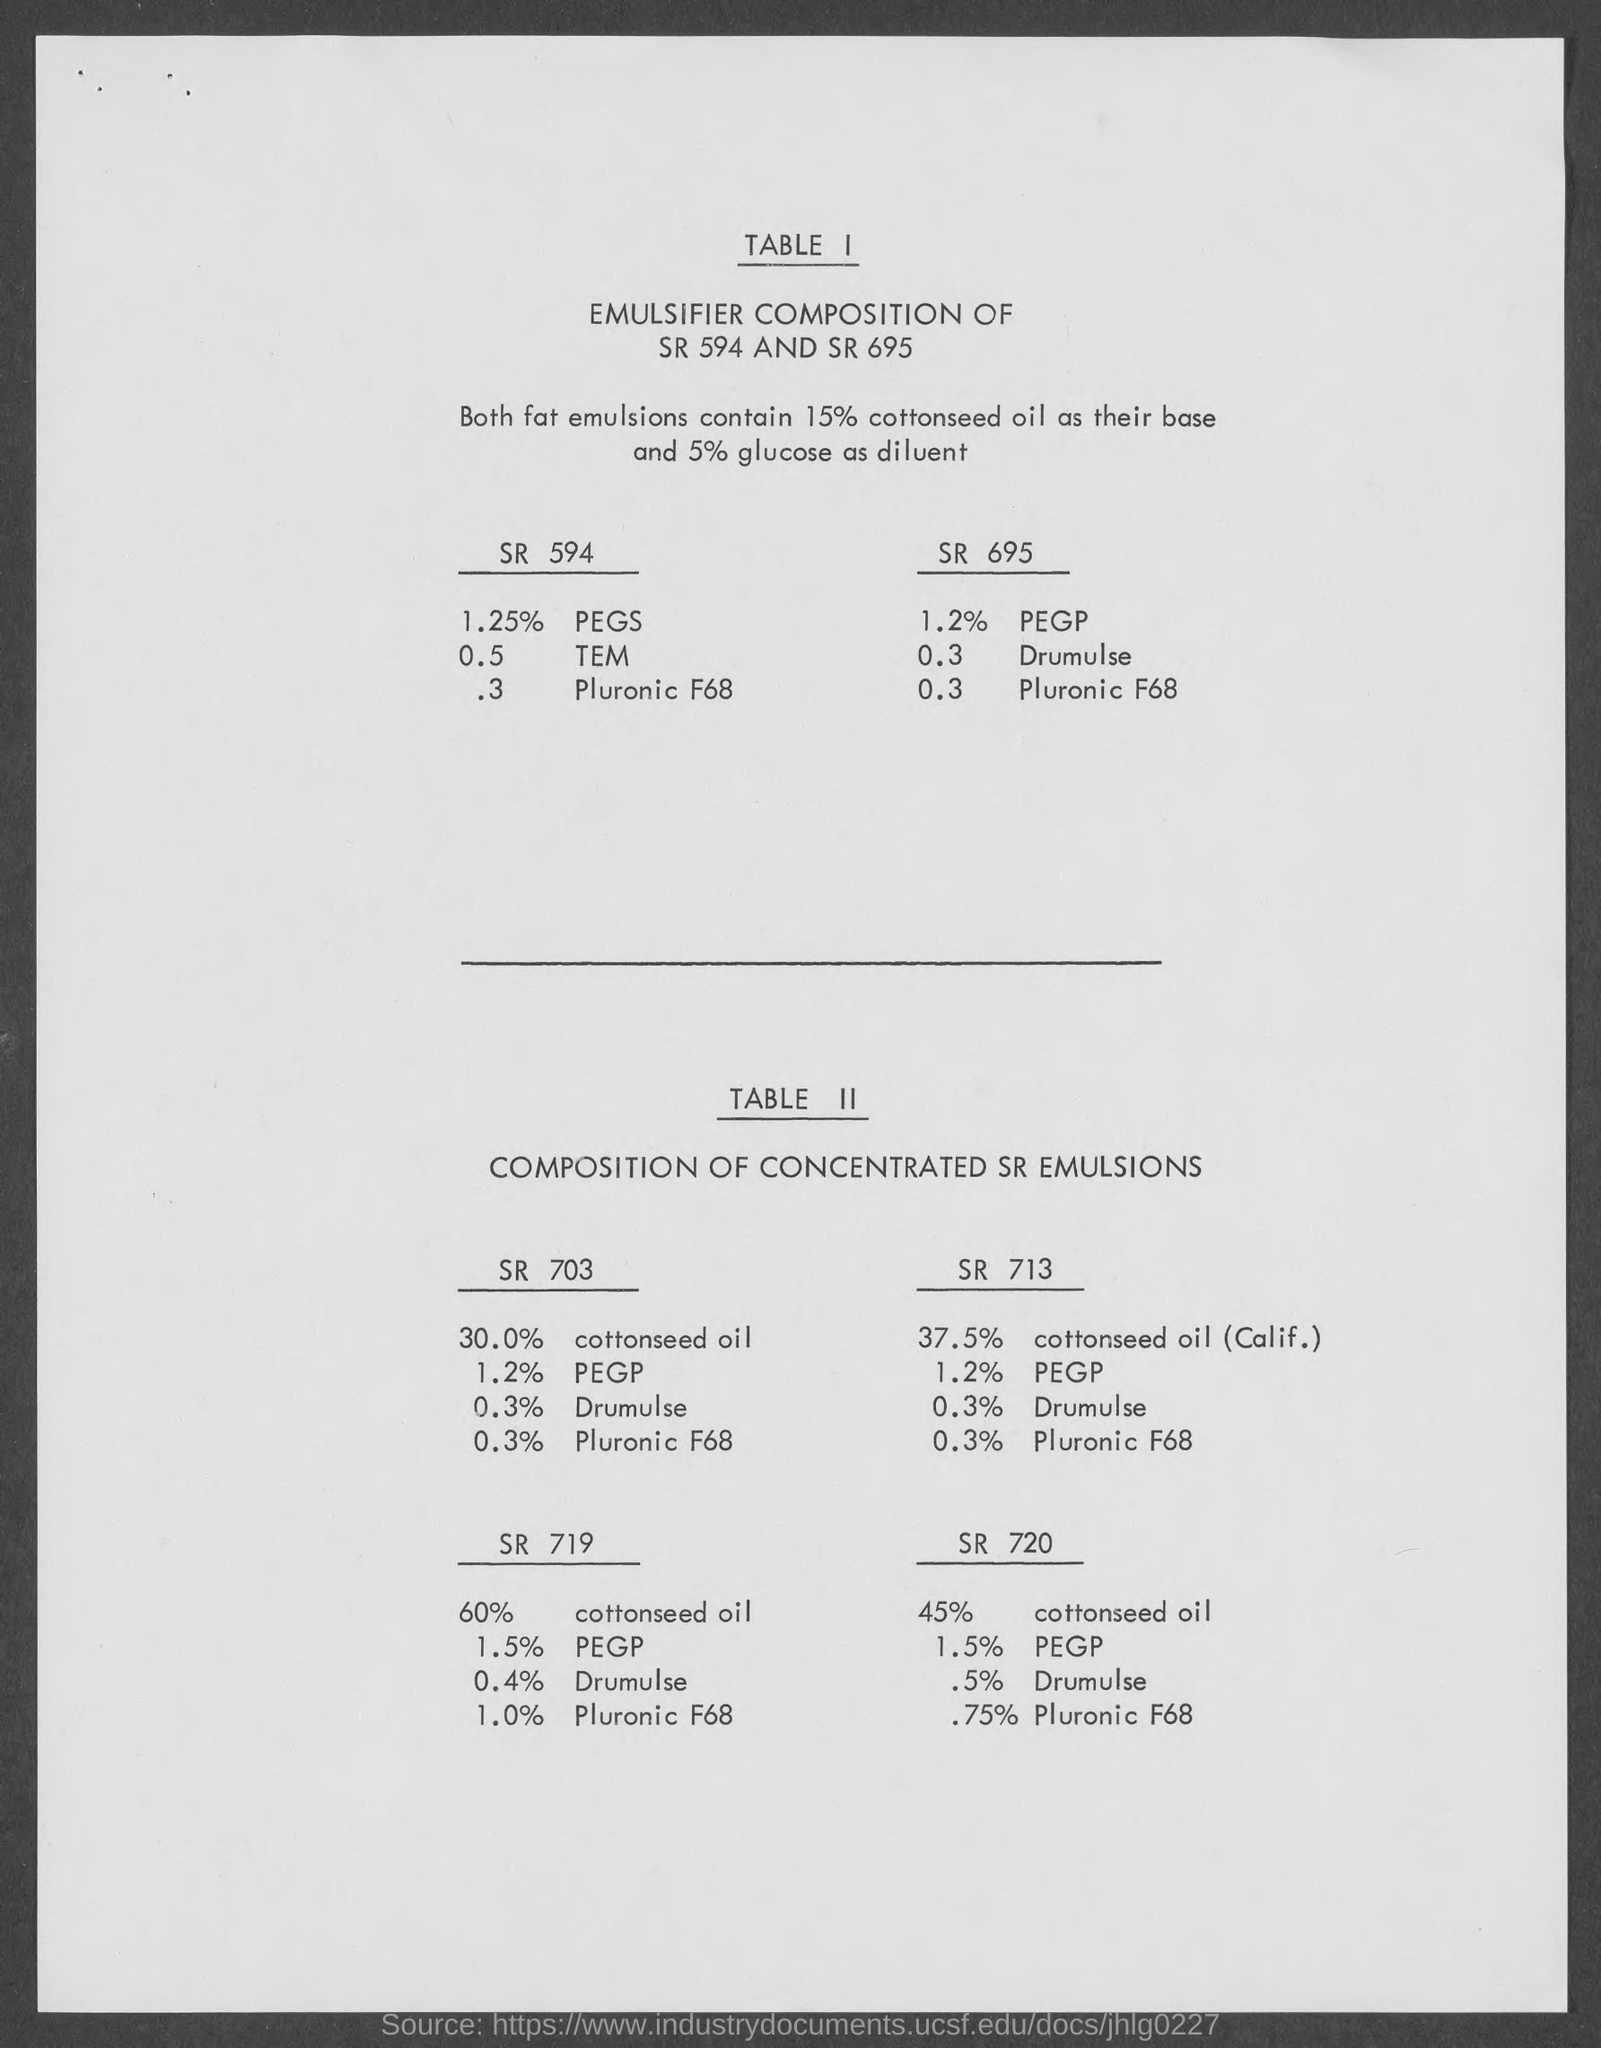List a handful of essential elements in this visual. The title of Table II is "Composition of Concentrated SE Emulsions. The title of table I is 'Emulsifier Composition of SR 594 and SR 695.' 